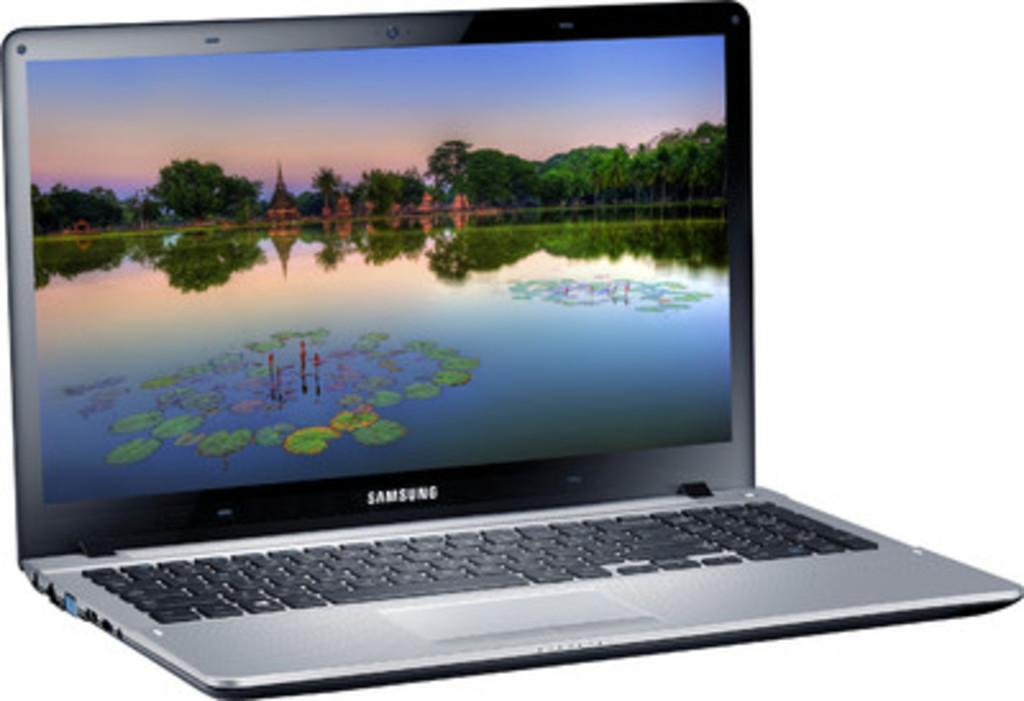Provide a one-sentence caption for the provided image. A Samsung laptop is open with a screensaver showing a pond. 